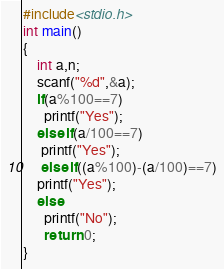<code> <loc_0><loc_0><loc_500><loc_500><_C_>#include<stdio.h>
int main()
{
	int a,n;
	scanf("%d",&a);
	if(a%100==7)
	  printf("Yes");
	else if(a/100==7)
	 printf("Yes");
	 else if((a%100)-(a/100)==7)
	printf("Yes");
	else
	  printf("No");
	  return 0;
}</code> 